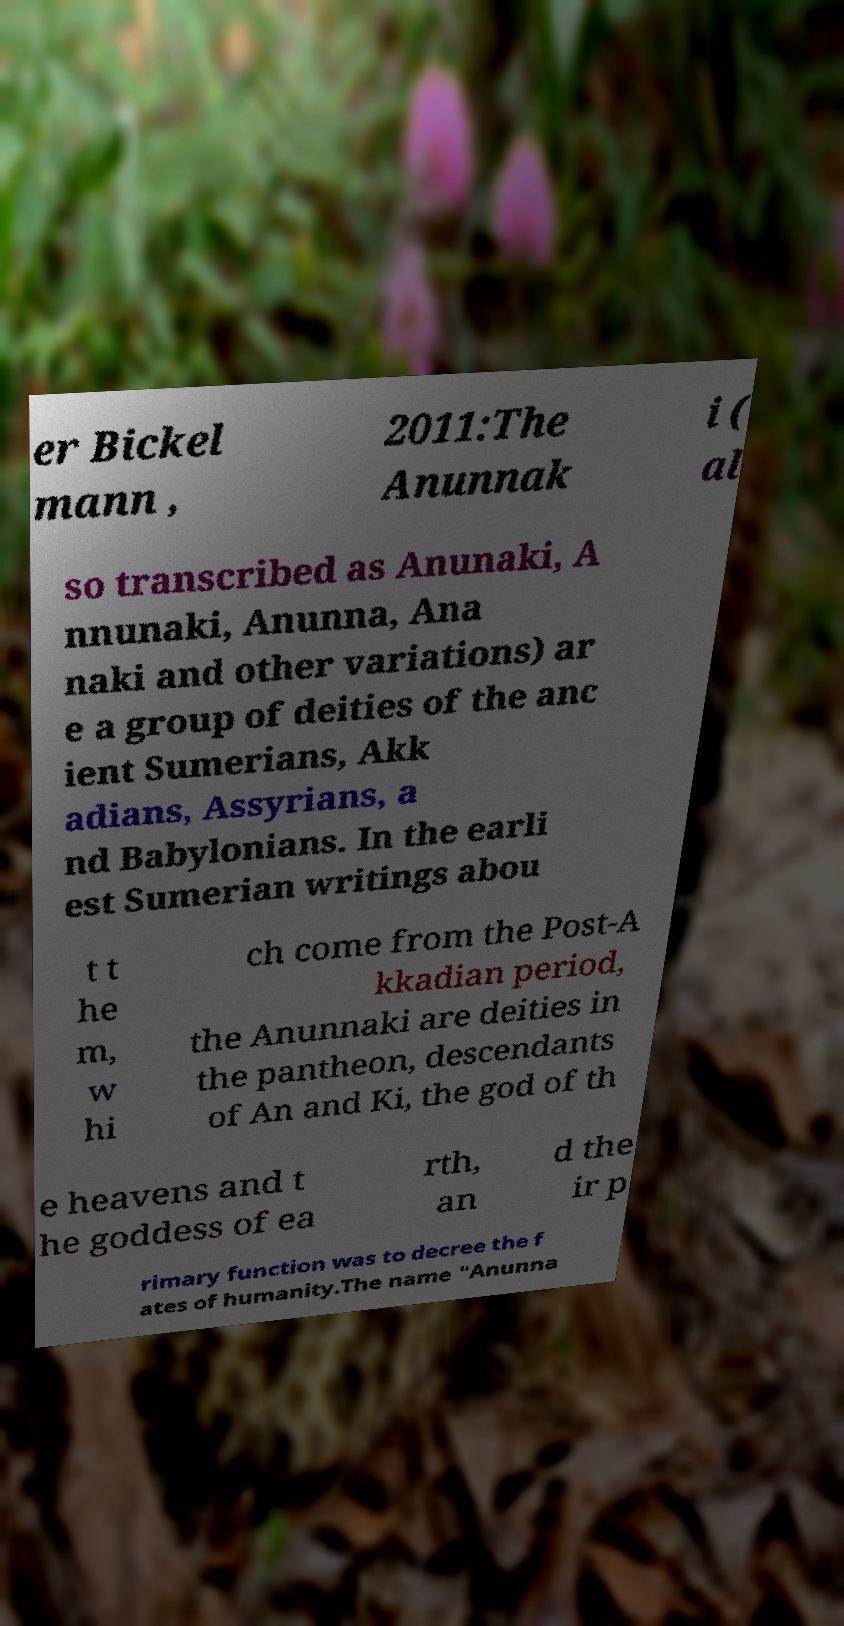For documentation purposes, I need the text within this image transcribed. Could you provide that? er Bickel mann , 2011:The Anunnak i ( al so transcribed as Anunaki, A nnunaki, Anunna, Ana naki and other variations) ar e a group of deities of the anc ient Sumerians, Akk adians, Assyrians, a nd Babylonians. In the earli est Sumerian writings abou t t he m, w hi ch come from the Post-A kkadian period, the Anunnaki are deities in the pantheon, descendants of An and Ki, the god of th e heavens and t he goddess of ea rth, an d the ir p rimary function was to decree the f ates of humanity.The name "Anunna 